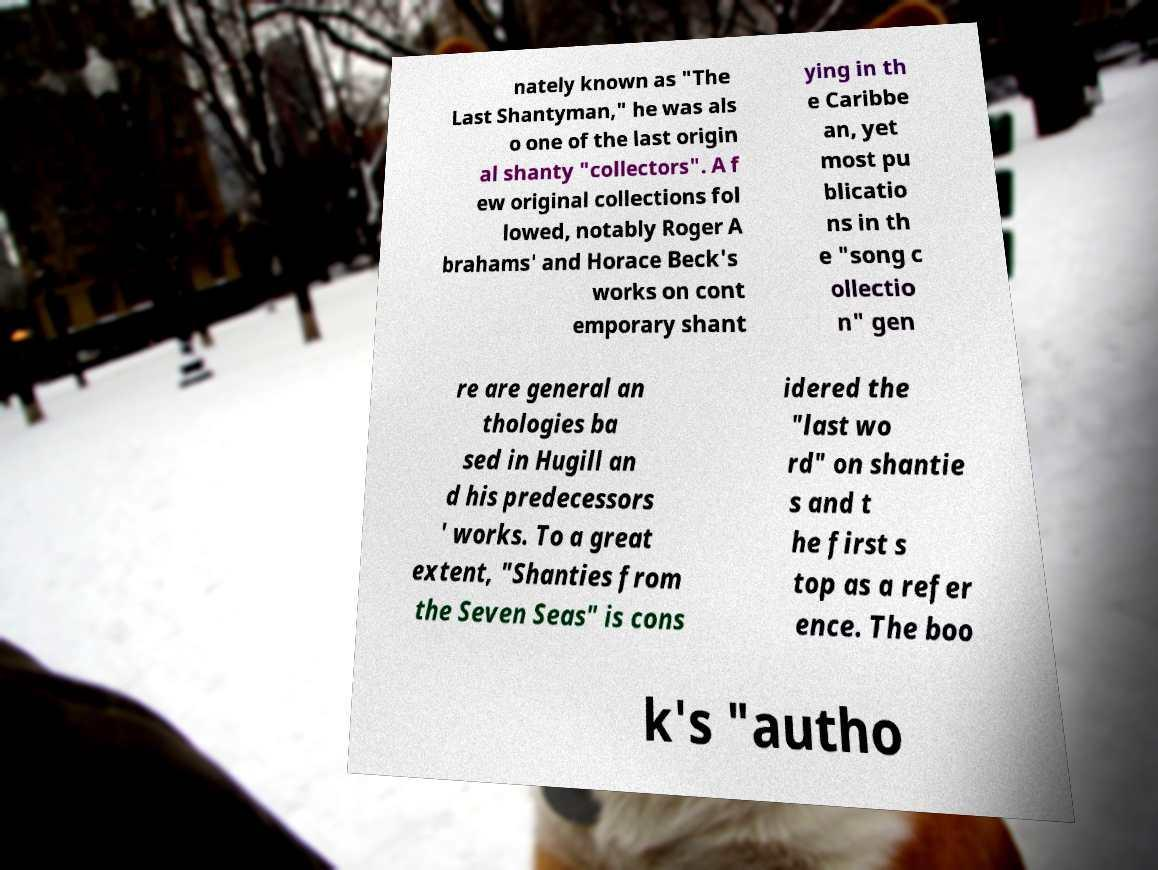What messages or text are displayed in this image? I need them in a readable, typed format. nately known as "The Last Shantyman," he was als o one of the last origin al shanty "collectors". A f ew original collections fol lowed, notably Roger A brahams' and Horace Beck's works on cont emporary shant ying in th e Caribbe an, yet most pu blicatio ns in th e "song c ollectio n" gen re are general an thologies ba sed in Hugill an d his predecessors ' works. To a great extent, "Shanties from the Seven Seas" is cons idered the "last wo rd" on shantie s and t he first s top as a refer ence. The boo k's "autho 